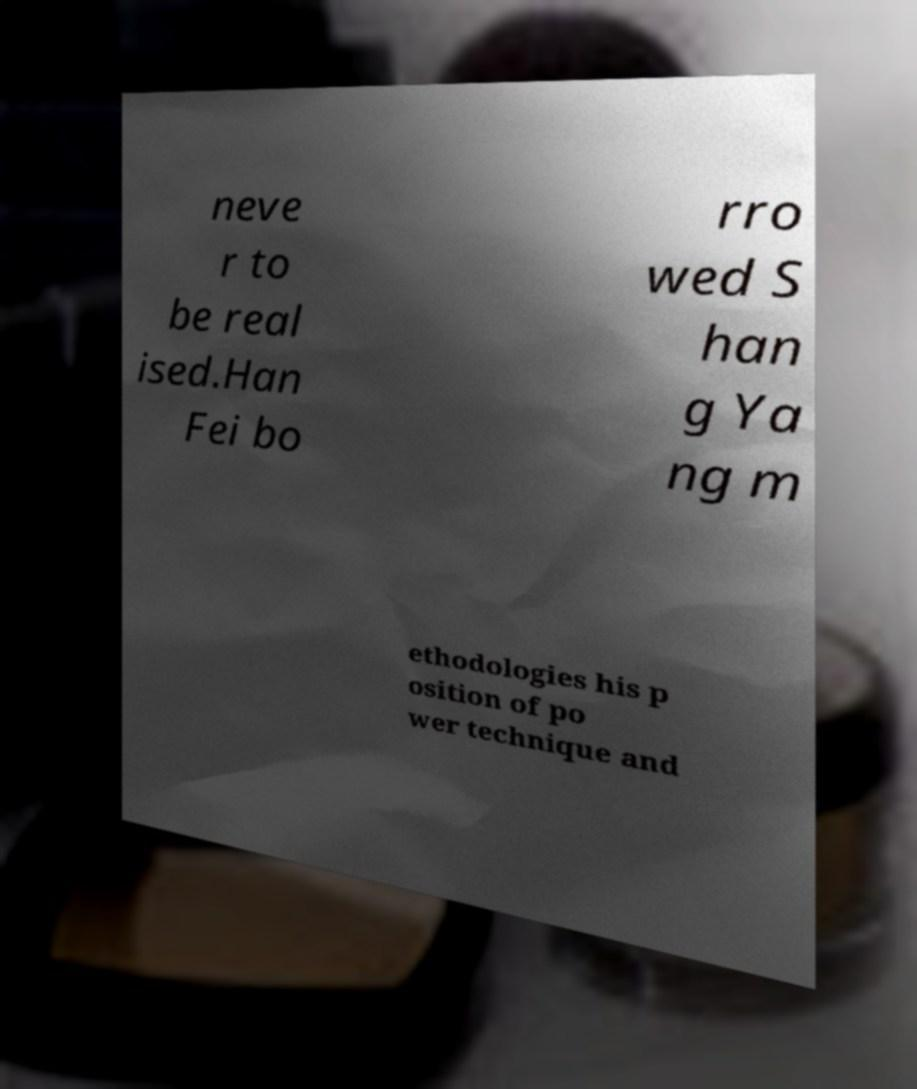Please read and relay the text visible in this image. What does it say? neve r to be real ised.Han Fei bo rro wed S han g Ya ng m ethodologies his p osition of po wer technique and 